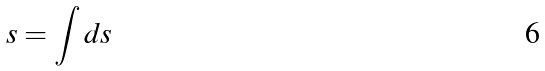<formula> <loc_0><loc_0><loc_500><loc_500>s = \int d s</formula> 